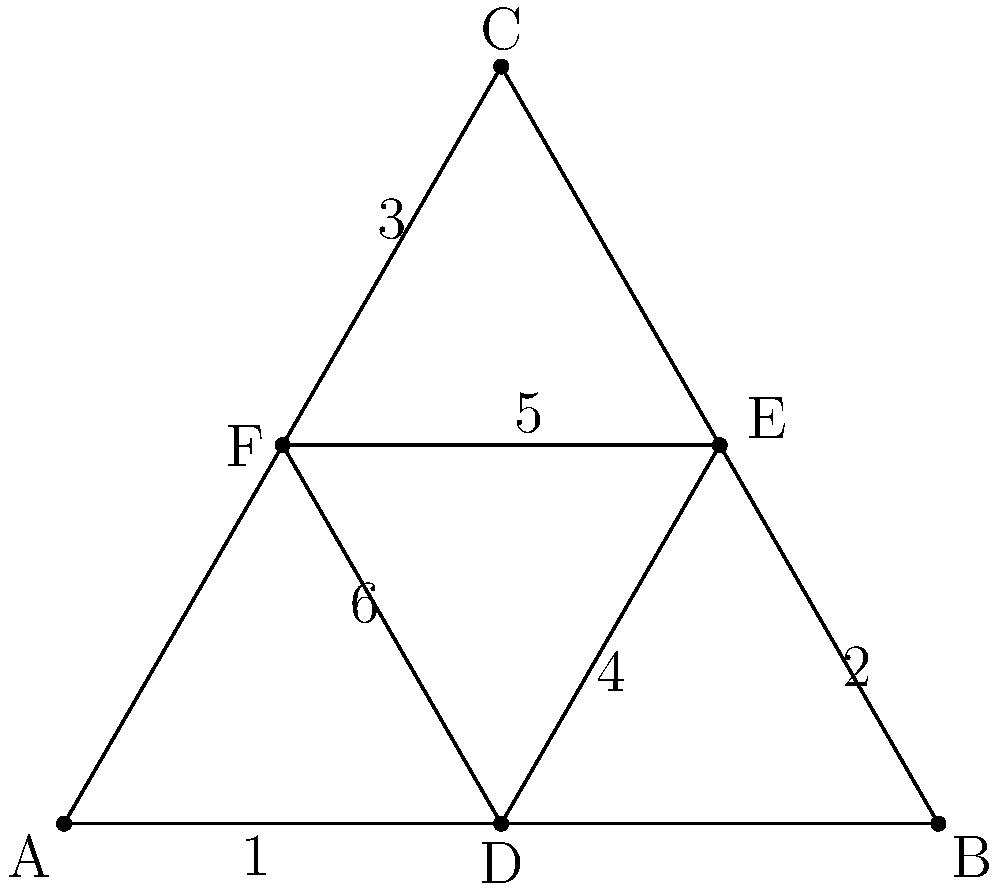In this Wild West sheriff's badge design, which pair of angles is congruent to the pair of angles labeled 1 and 4? Let's approach this step-by-step:

1) First, we need to recognize that this sheriff's badge is based on a regular hexagram, formed by two equilateral triangles.

2) In an equilateral triangle, all angles are equal and measure 60°.

3) The hexagram is formed by overlapping two equilateral triangles, creating six congruent smaller triangles.

4) Angles 1 and 4 are base angles of two of these smaller triangles.

5) Since these smaller triangles are congruent, their corresponding angles are congruent.

6) Looking at the symmetry of the hexagram, we can see that angles 2 and 5 are in the same position in their respective small triangles as 1 and 4.

7) Similarly, angles 3 and 6 are also in the same position in their respective small triangles.

8) Therefore, angles 1 and 4 are congruent to both pairs 2 and 5, and 3 and 6.

9) However, the question asks for a single pair, so we need to choose one.

10) The pair 2 and 5 is positioned symmetrically opposite to 1 and 4, making it the most visually similar choice.
Answer: 2 and 5 